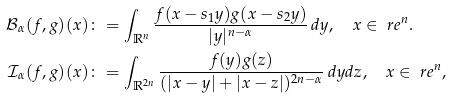Convert formula to latex. <formula><loc_0><loc_0><loc_500><loc_500>\mathcal { B } _ { \alpha } ( f , g ) ( x ) & \colon = \int _ { { \mathbb { R } } ^ { n } } \frac { f ( x - s _ { 1 } y ) g ( x - s _ { 2 } y ) } { | y | ^ { n - \alpha } } \, d y , \quad x \in \ r e ^ { n } . \\ \mathcal { I } _ { \alpha } ( f , g ) ( x ) & \colon = \int _ { { \mathbb { R } } ^ { 2 n } } \frac { f ( y ) g ( z ) } { ( | x - y | + | x - z | ) ^ { 2 n - \alpha } } \, d y d z , \quad x \in \ r e ^ { n } ,</formula> 